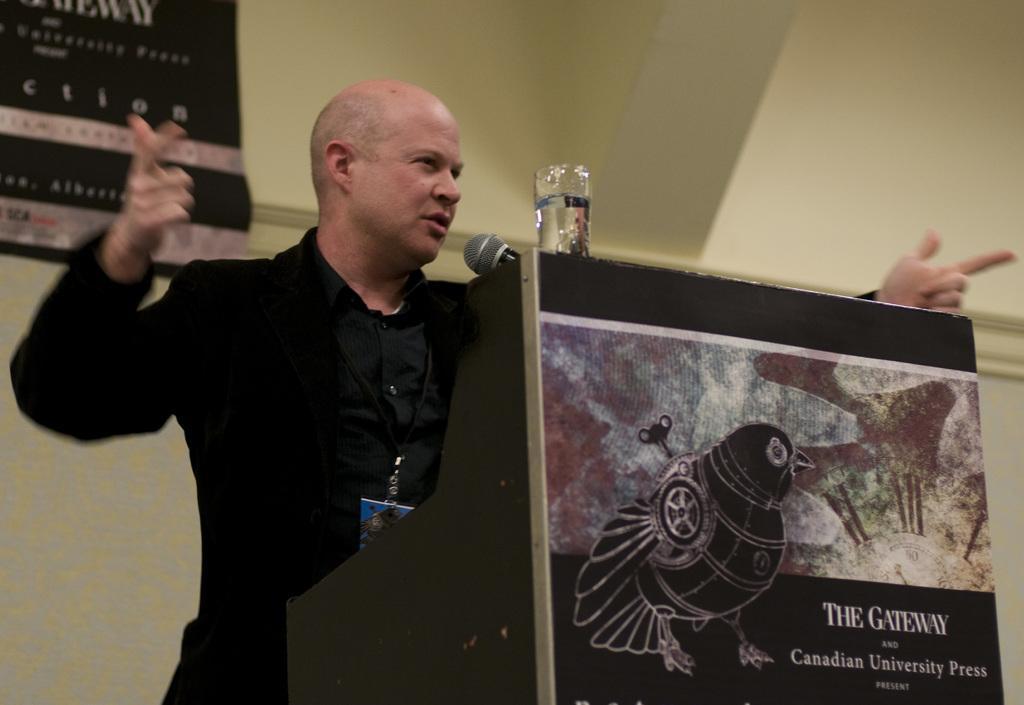In one or two sentences, can you explain what this image depicts? In this image, there is a man standing in front of a podium, on that podium there is a glass of water and a mic, in the background there is a wall, to that wall there is a banner, on that banner there is some text, on that podium there is a picture of a bird and a text. 